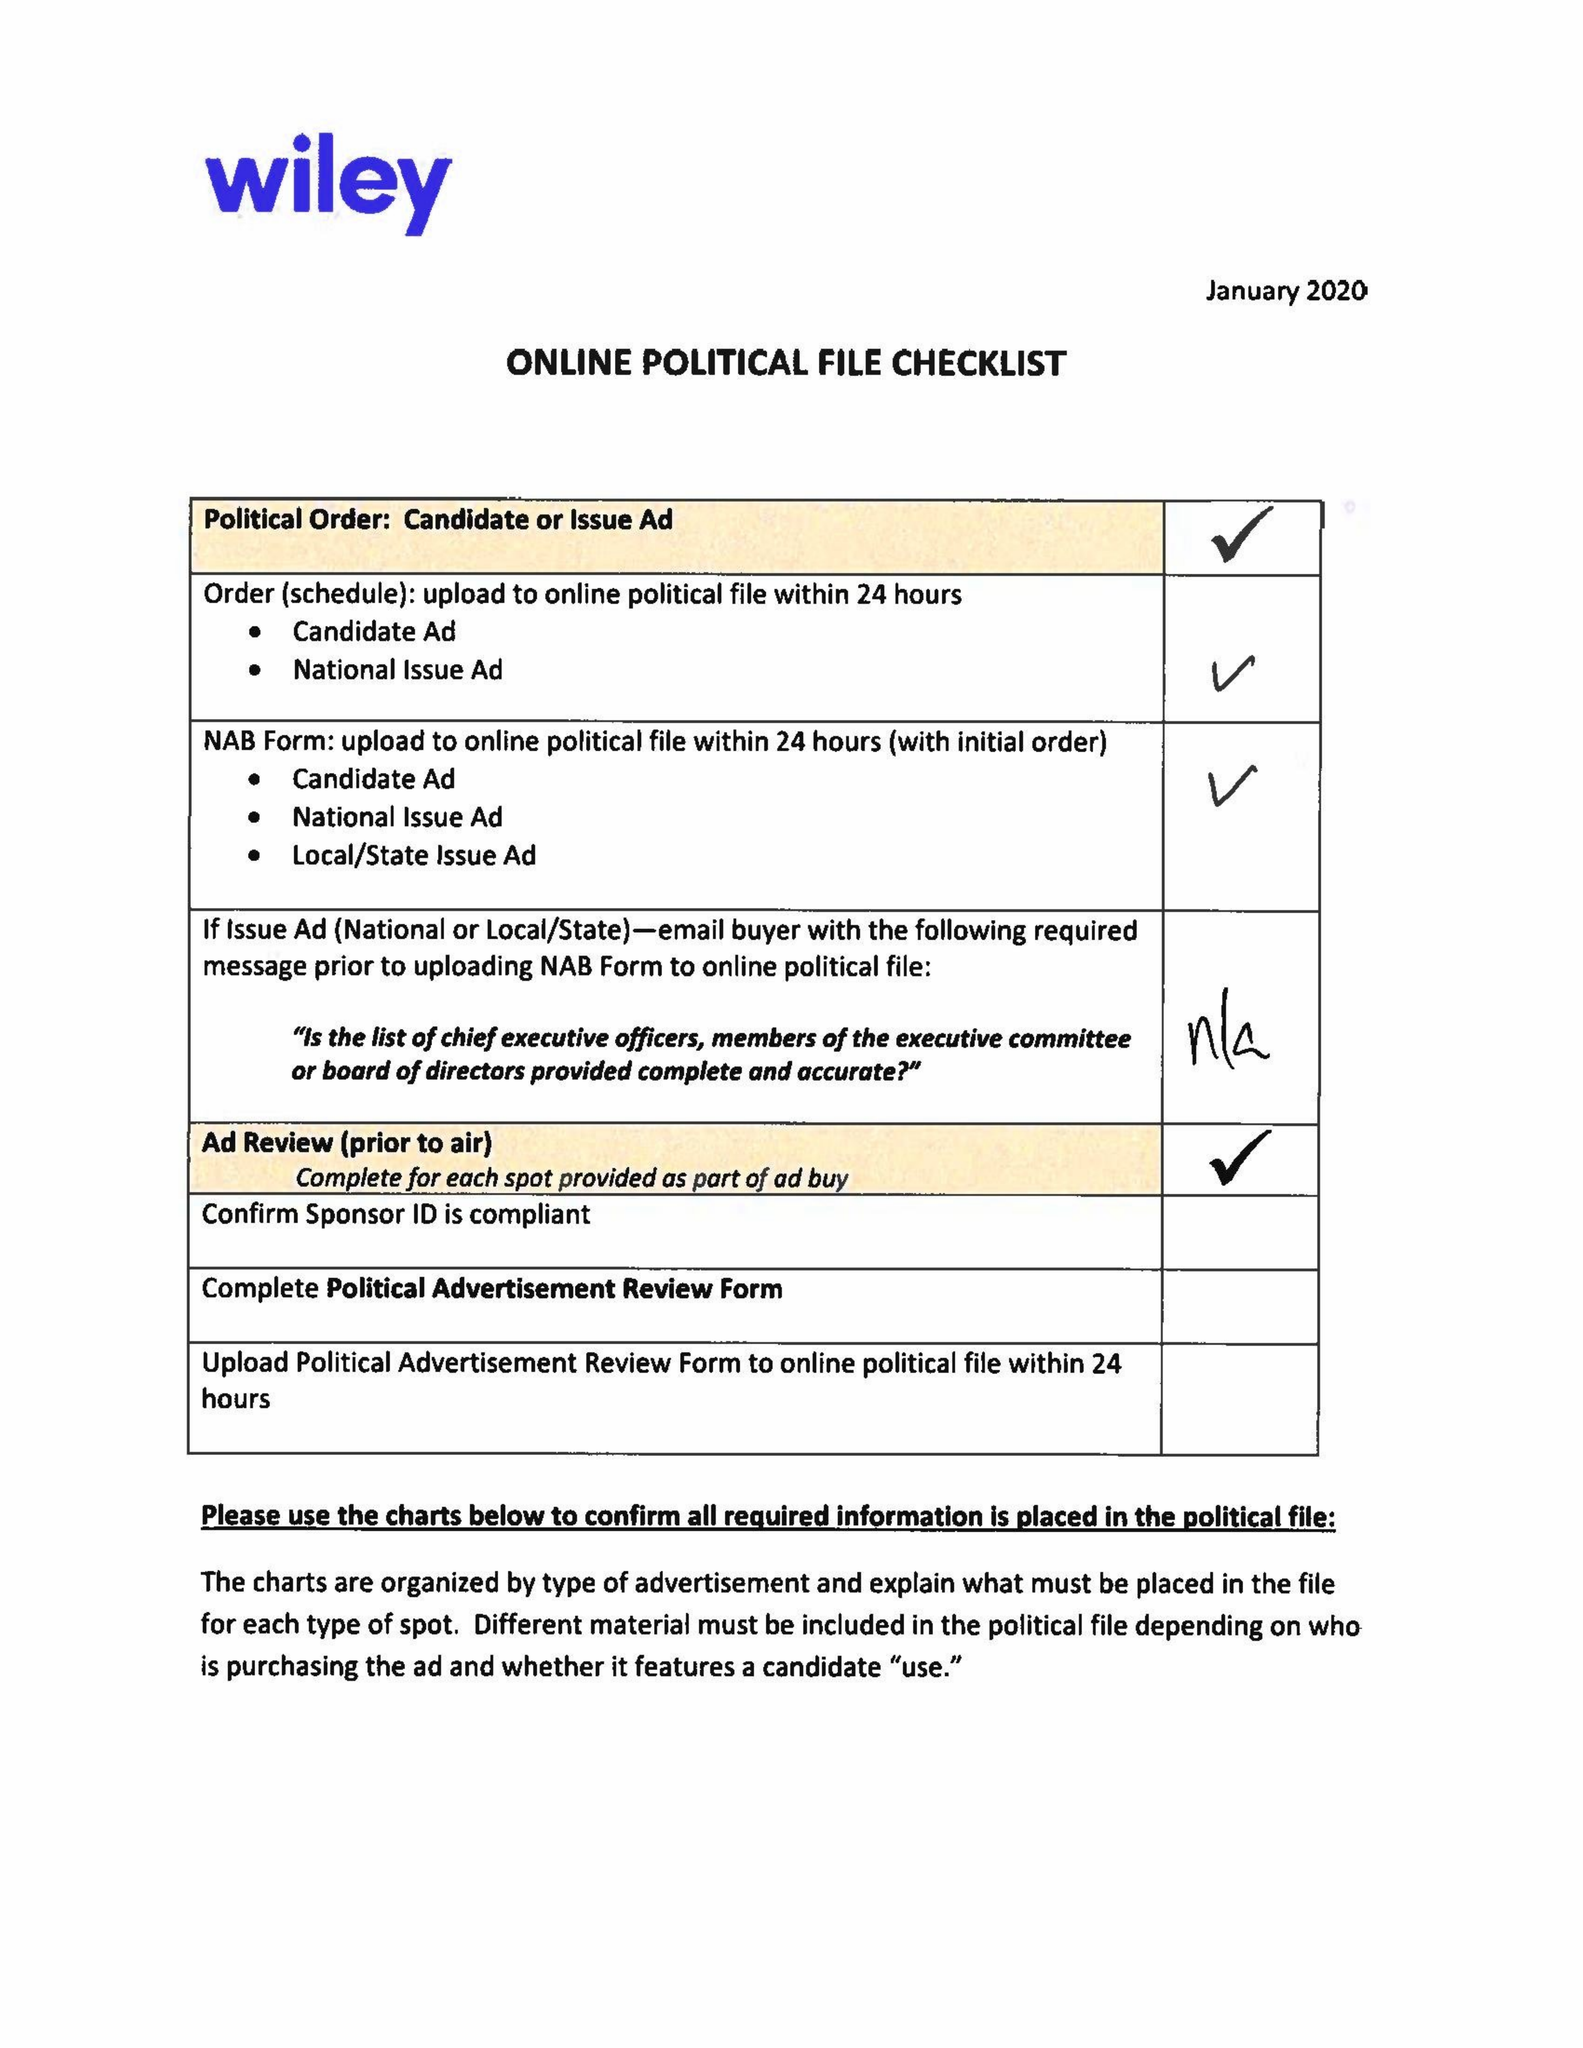What is the value for the flight_to?
Answer the question using a single word or phrase. 03/01/20 